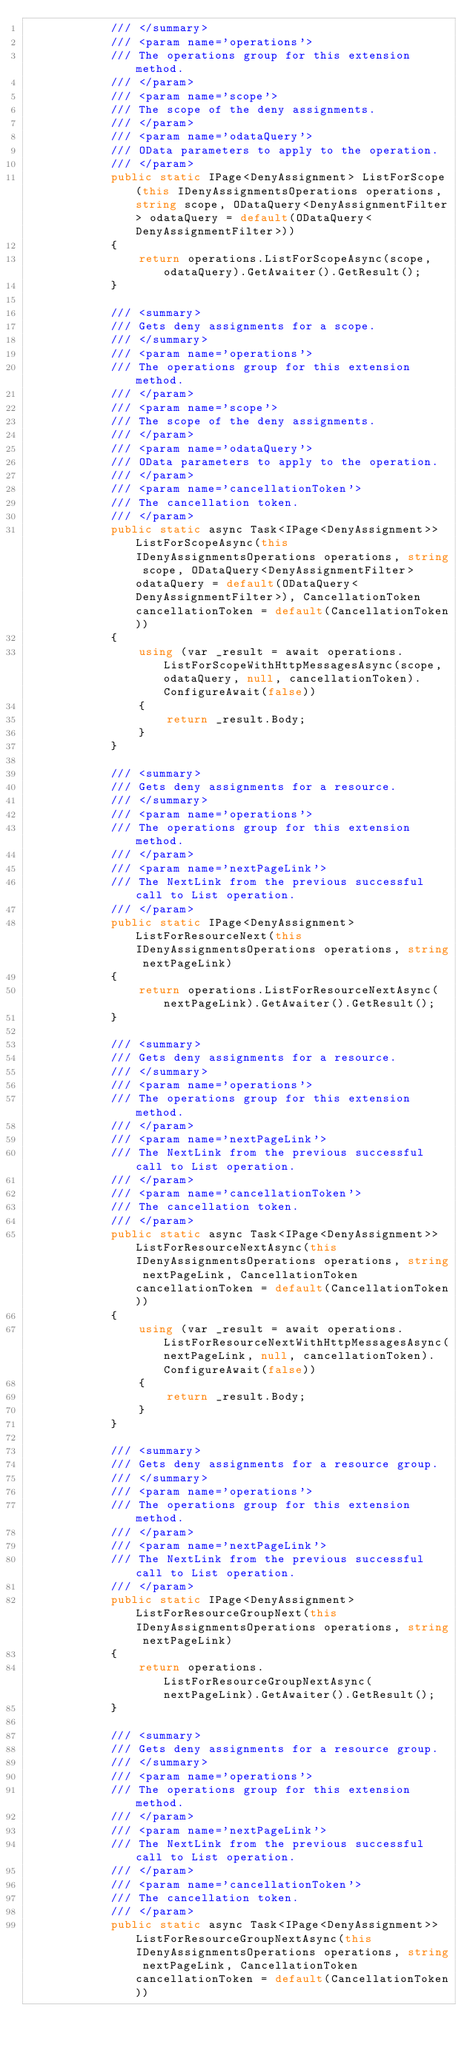Convert code to text. <code><loc_0><loc_0><loc_500><loc_500><_C#_>            /// </summary>
            /// <param name='operations'>
            /// The operations group for this extension method.
            /// </param>
            /// <param name='scope'>
            /// The scope of the deny assignments.
            /// </param>
            /// <param name='odataQuery'>
            /// OData parameters to apply to the operation.
            /// </param>
            public static IPage<DenyAssignment> ListForScope(this IDenyAssignmentsOperations operations, string scope, ODataQuery<DenyAssignmentFilter> odataQuery = default(ODataQuery<DenyAssignmentFilter>))
            {
                return operations.ListForScopeAsync(scope, odataQuery).GetAwaiter().GetResult();
            }

            /// <summary>
            /// Gets deny assignments for a scope.
            /// </summary>
            /// <param name='operations'>
            /// The operations group for this extension method.
            /// </param>
            /// <param name='scope'>
            /// The scope of the deny assignments.
            /// </param>
            /// <param name='odataQuery'>
            /// OData parameters to apply to the operation.
            /// </param>
            /// <param name='cancellationToken'>
            /// The cancellation token.
            /// </param>
            public static async Task<IPage<DenyAssignment>> ListForScopeAsync(this IDenyAssignmentsOperations operations, string scope, ODataQuery<DenyAssignmentFilter> odataQuery = default(ODataQuery<DenyAssignmentFilter>), CancellationToken cancellationToken = default(CancellationToken))
            {
                using (var _result = await operations.ListForScopeWithHttpMessagesAsync(scope, odataQuery, null, cancellationToken).ConfigureAwait(false))
                {
                    return _result.Body;
                }
            }

            /// <summary>
            /// Gets deny assignments for a resource.
            /// </summary>
            /// <param name='operations'>
            /// The operations group for this extension method.
            /// </param>
            /// <param name='nextPageLink'>
            /// The NextLink from the previous successful call to List operation.
            /// </param>
            public static IPage<DenyAssignment> ListForResourceNext(this IDenyAssignmentsOperations operations, string nextPageLink)
            {
                return operations.ListForResourceNextAsync(nextPageLink).GetAwaiter().GetResult();
            }

            /// <summary>
            /// Gets deny assignments for a resource.
            /// </summary>
            /// <param name='operations'>
            /// The operations group for this extension method.
            /// </param>
            /// <param name='nextPageLink'>
            /// The NextLink from the previous successful call to List operation.
            /// </param>
            /// <param name='cancellationToken'>
            /// The cancellation token.
            /// </param>
            public static async Task<IPage<DenyAssignment>> ListForResourceNextAsync(this IDenyAssignmentsOperations operations, string nextPageLink, CancellationToken cancellationToken = default(CancellationToken))
            {
                using (var _result = await operations.ListForResourceNextWithHttpMessagesAsync(nextPageLink, null, cancellationToken).ConfigureAwait(false))
                {
                    return _result.Body;
                }
            }

            /// <summary>
            /// Gets deny assignments for a resource group.
            /// </summary>
            /// <param name='operations'>
            /// The operations group for this extension method.
            /// </param>
            /// <param name='nextPageLink'>
            /// The NextLink from the previous successful call to List operation.
            /// </param>
            public static IPage<DenyAssignment> ListForResourceGroupNext(this IDenyAssignmentsOperations operations, string nextPageLink)
            {
                return operations.ListForResourceGroupNextAsync(nextPageLink).GetAwaiter().GetResult();
            }

            /// <summary>
            /// Gets deny assignments for a resource group.
            /// </summary>
            /// <param name='operations'>
            /// The operations group for this extension method.
            /// </param>
            /// <param name='nextPageLink'>
            /// The NextLink from the previous successful call to List operation.
            /// </param>
            /// <param name='cancellationToken'>
            /// The cancellation token.
            /// </param>
            public static async Task<IPage<DenyAssignment>> ListForResourceGroupNextAsync(this IDenyAssignmentsOperations operations, string nextPageLink, CancellationToken cancellationToken = default(CancellationToken))</code> 